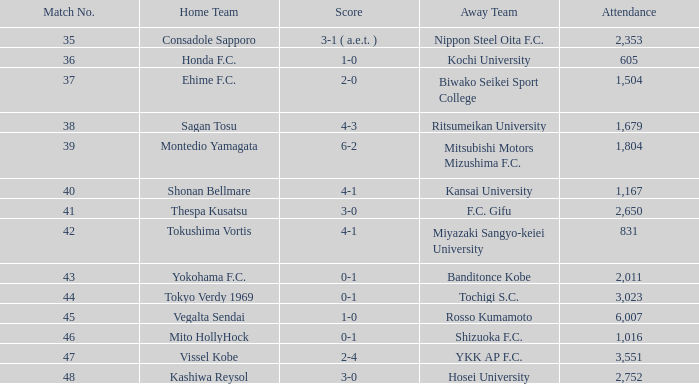Post match 43, what was the attendance figure for the game that ended 2-4? 3551.0. 